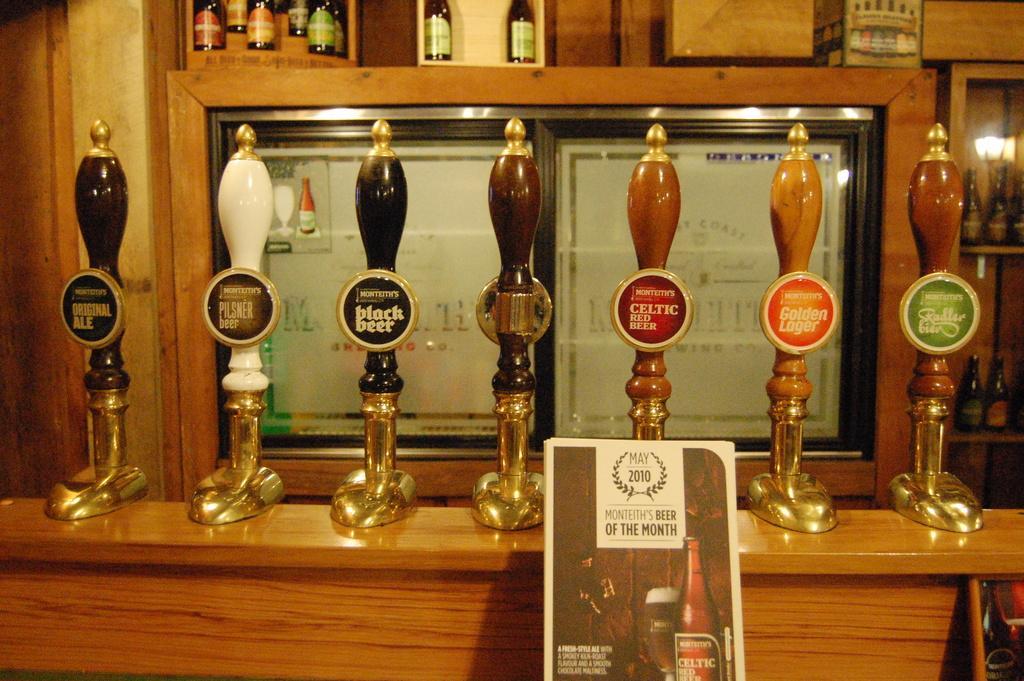How would you summarize this image in a sentence or two? In this image I can see there is a table. On the table there are shields. And there is a board with text and image. And at the back there is a shelf, in that there are bottles and a box and there is a frame. 